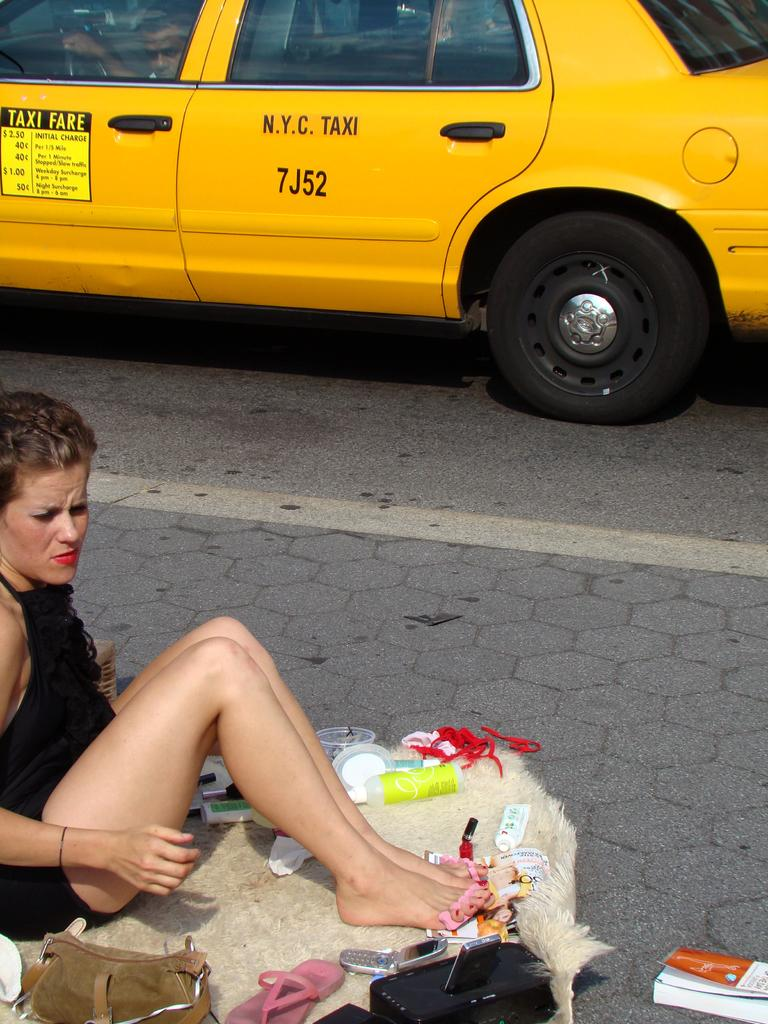<image>
Describe the image concisely. A woman paints her toes on the street next to a N.Y.C. Taxi. 